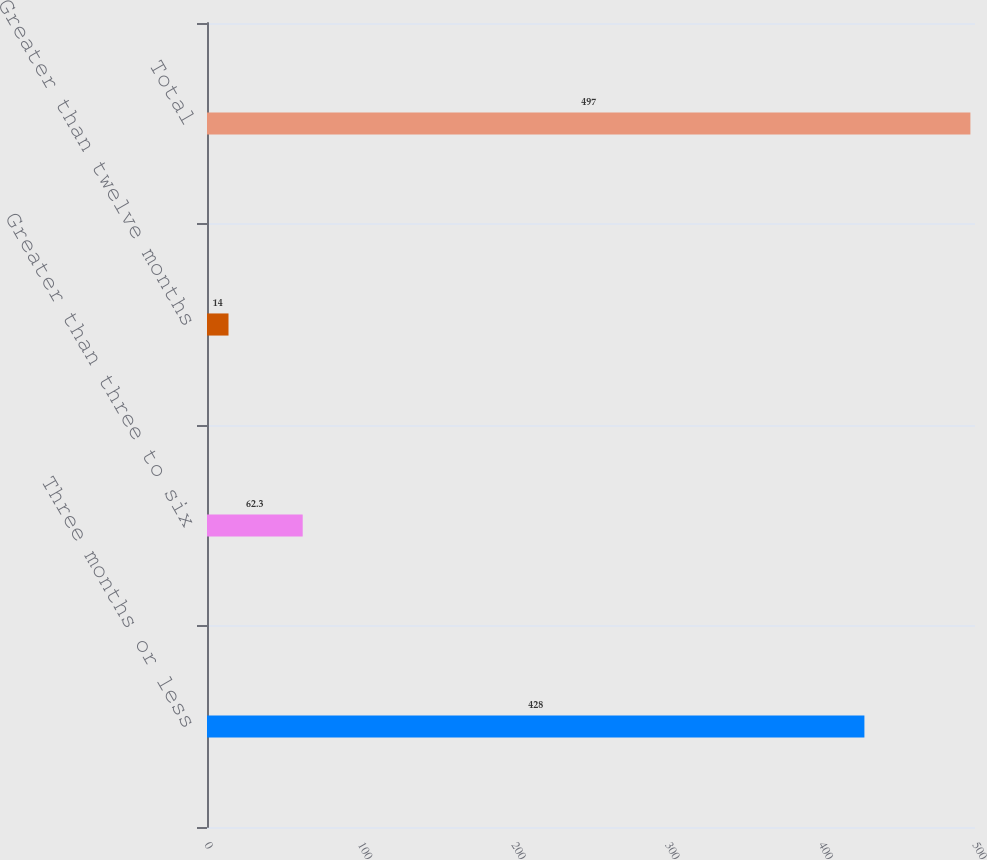Convert chart to OTSL. <chart><loc_0><loc_0><loc_500><loc_500><bar_chart><fcel>Three months or less<fcel>Greater than three to six<fcel>Greater than twelve months<fcel>Total<nl><fcel>428<fcel>62.3<fcel>14<fcel>497<nl></chart> 